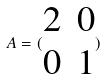<formula> <loc_0><loc_0><loc_500><loc_500>A = ( \begin{matrix} 2 & 0 \\ 0 & 1 \end{matrix} )</formula> 